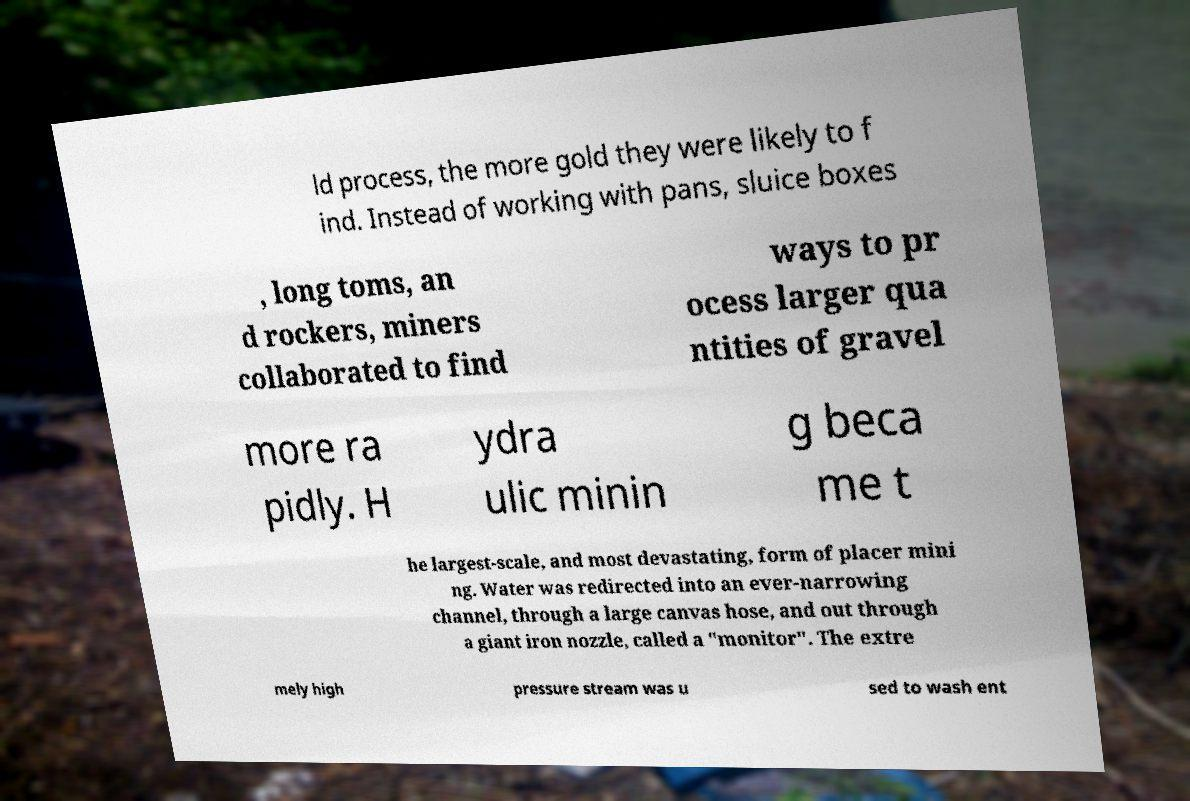For documentation purposes, I need the text within this image transcribed. Could you provide that? ld process, the more gold they were likely to f ind. Instead of working with pans, sluice boxes , long toms, an d rockers, miners collaborated to find ways to pr ocess larger qua ntities of gravel more ra pidly. H ydra ulic minin g beca me t he largest-scale, and most devastating, form of placer mini ng. Water was redirected into an ever-narrowing channel, through a large canvas hose, and out through a giant iron nozzle, called a "monitor". The extre mely high pressure stream was u sed to wash ent 